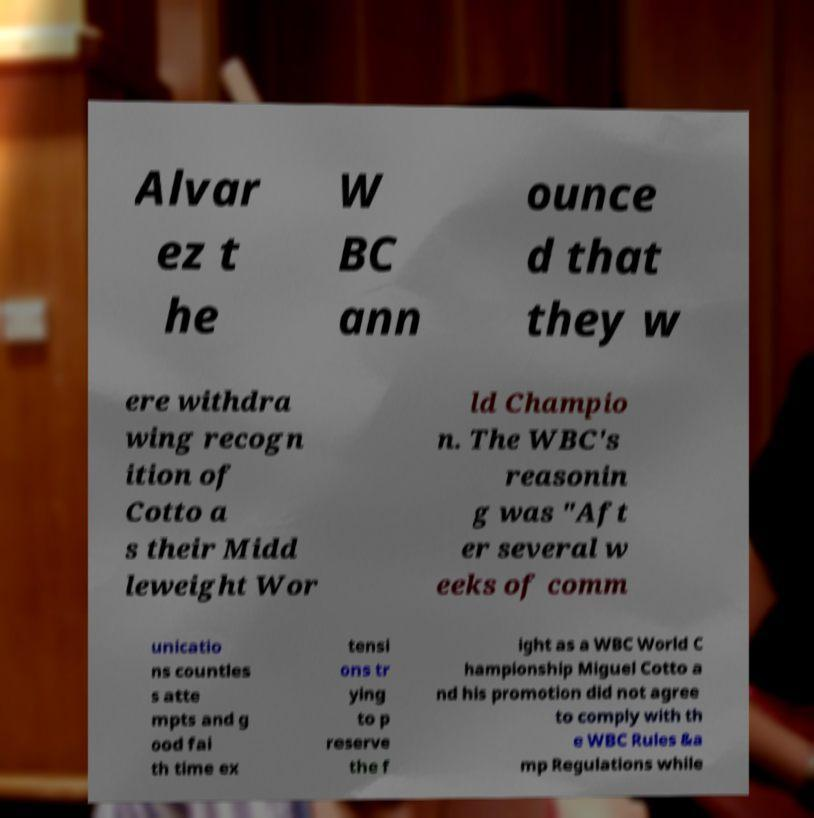For documentation purposes, I need the text within this image transcribed. Could you provide that? Alvar ez t he W BC ann ounce d that they w ere withdra wing recogn ition of Cotto a s their Midd leweight Wor ld Champio n. The WBC's reasonin g was "Aft er several w eeks of comm unicatio ns countles s atte mpts and g ood fai th time ex tensi ons tr ying to p reserve the f ight as a WBC World C hampionship Miguel Cotto a nd his promotion did not agree to comply with th e WBC Rules &a mp Regulations while 